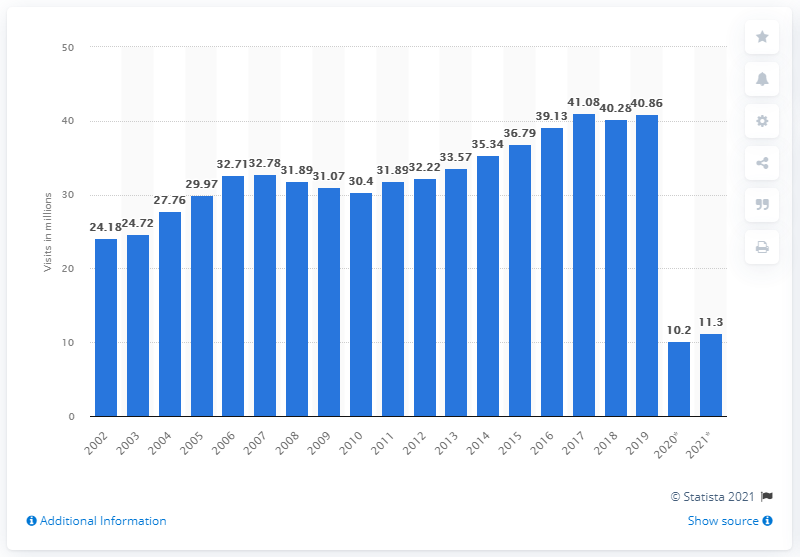List a handful of essential elements in this visual. In 2020, it is estimated that approximately 10.2 million tourists will visit the United Kingdom from abroad. In 2019, the peak number of overseas visits to the UK was approximately 40.86 million. The number of overseas visits to the UK is expected to increase to 11.3 million in 2021. 